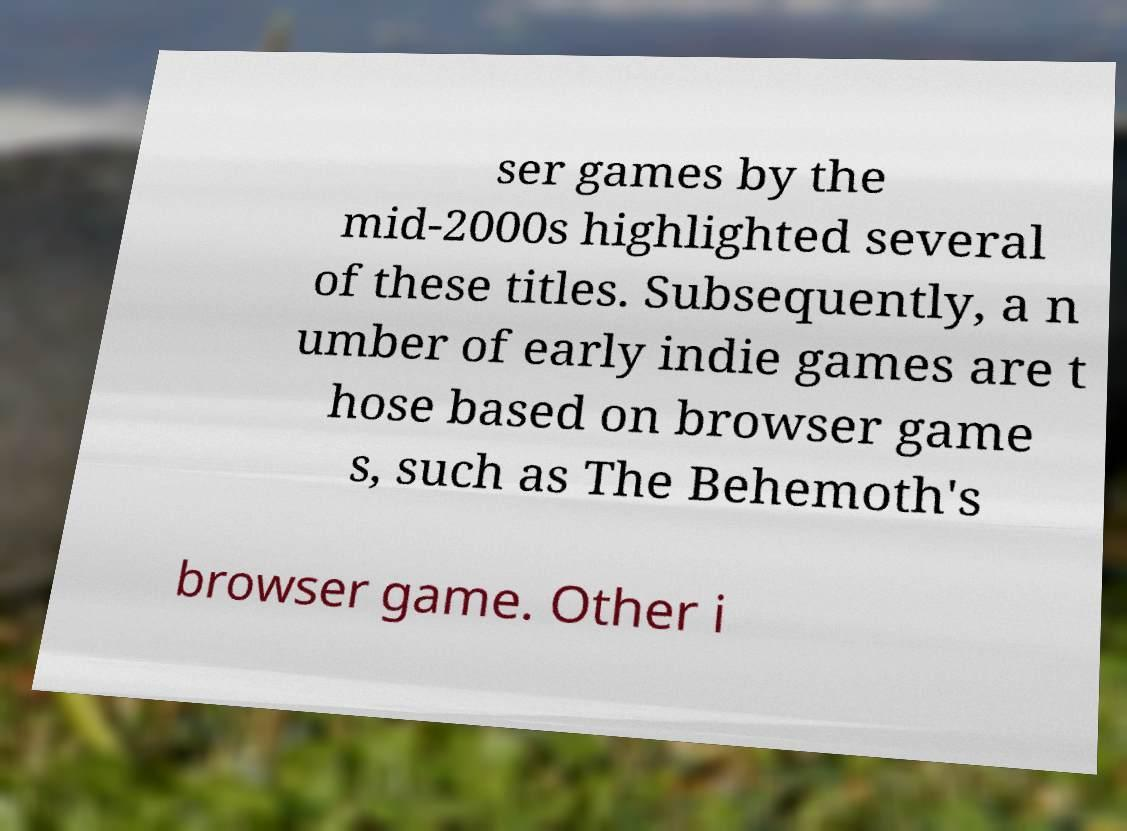I need the written content from this picture converted into text. Can you do that? ser games by the mid-2000s highlighted several of these titles. Subsequently, a n umber of early indie games are t hose based on browser game s, such as The Behemoth's browser game. Other i 